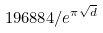Convert formula to latex. <formula><loc_0><loc_0><loc_500><loc_500>1 9 6 8 8 4 / e ^ { \pi \sqrt { d } }</formula> 